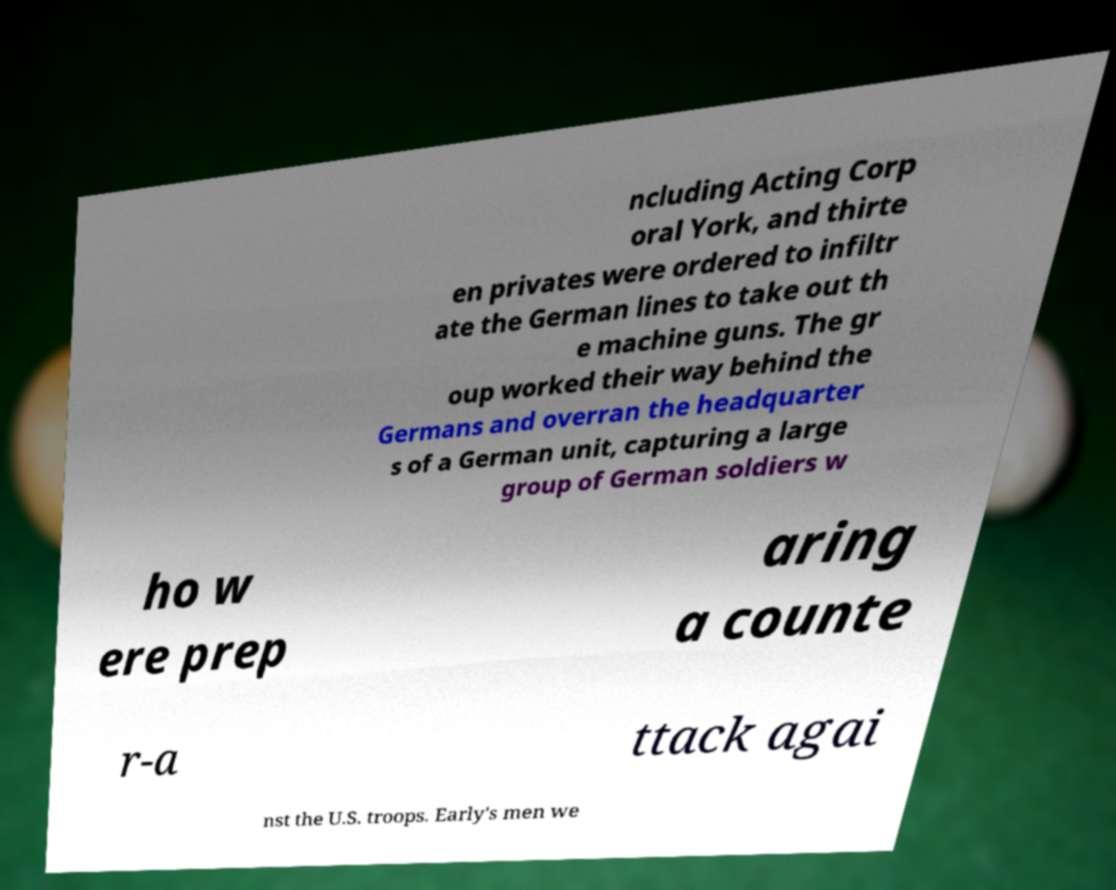I need the written content from this picture converted into text. Can you do that? ncluding Acting Corp oral York, and thirte en privates were ordered to infiltr ate the German lines to take out th e machine guns. The gr oup worked their way behind the Germans and overran the headquarter s of a German unit, capturing a large group of German soldiers w ho w ere prep aring a counte r-a ttack agai nst the U.S. troops. Early's men we 